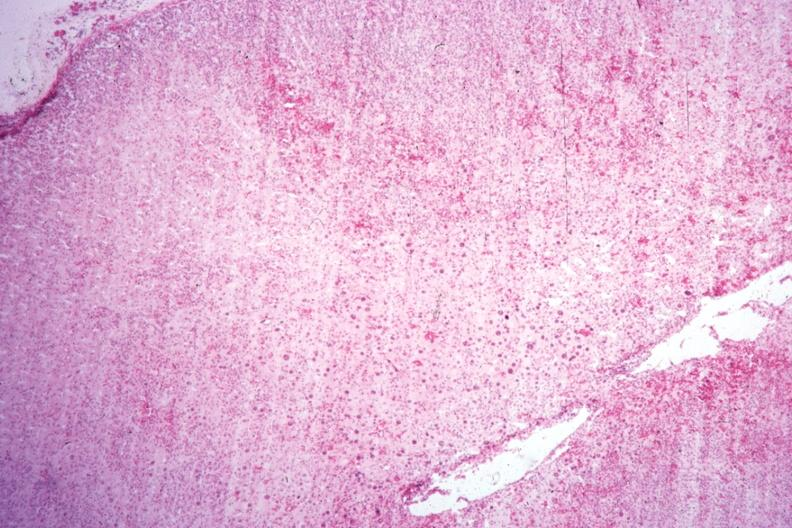what does this image show?
Answer the question using a single word or phrase. Localization of cytomegaly well shown 